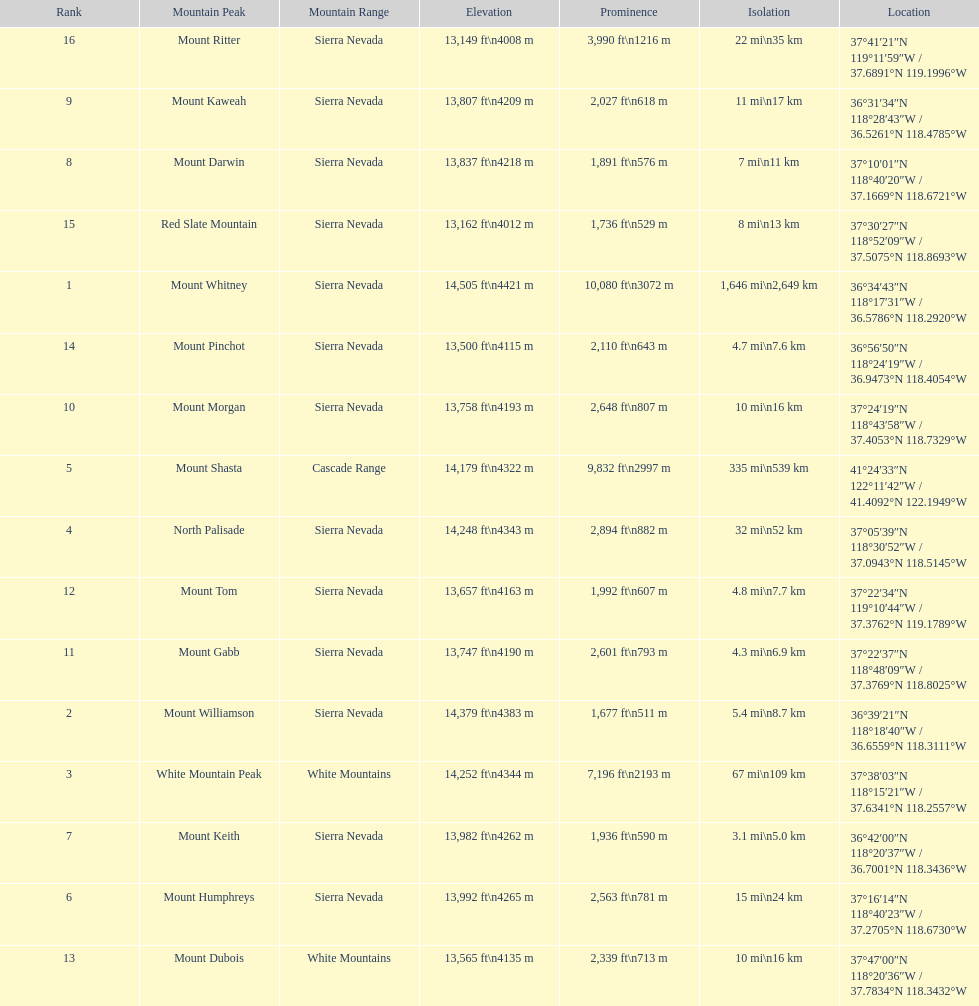Which mountain peak is no higher than 13,149 ft? Mount Ritter. 